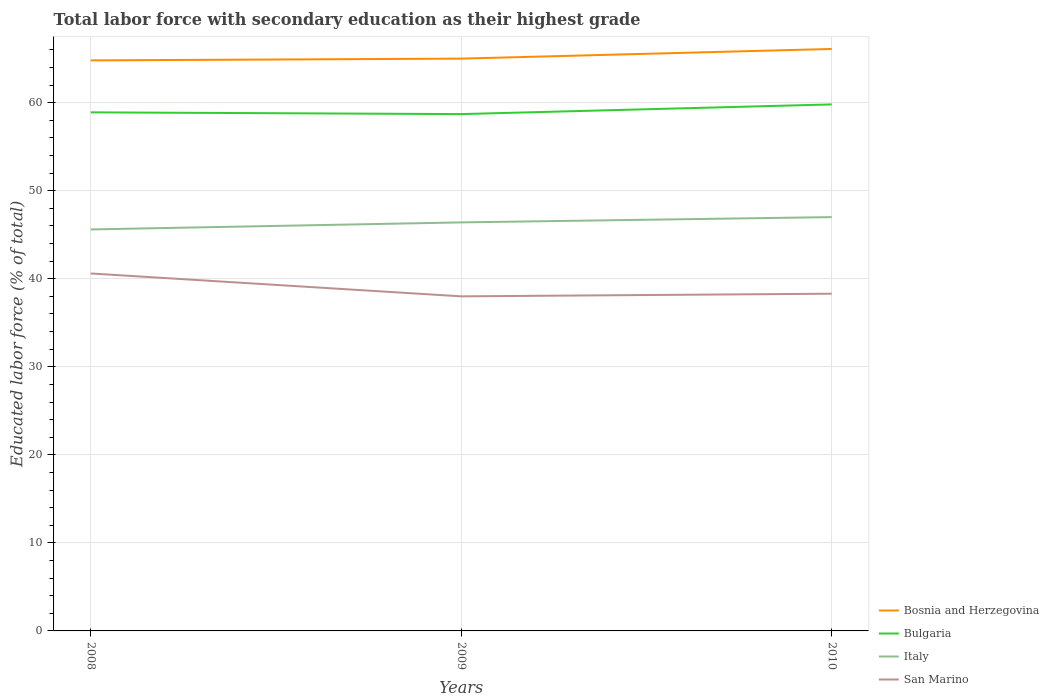Is the number of lines equal to the number of legend labels?
Make the answer very short. Yes. Across all years, what is the maximum percentage of total labor force with primary education in Italy?
Your answer should be very brief. 45.6. In which year was the percentage of total labor force with primary education in Italy maximum?
Provide a short and direct response. 2008. What is the total percentage of total labor force with primary education in Bulgaria in the graph?
Your answer should be very brief. -0.9. What is the difference between the highest and the second highest percentage of total labor force with primary education in San Marino?
Your answer should be very brief. 2.6. What is the difference between the highest and the lowest percentage of total labor force with primary education in San Marino?
Give a very brief answer. 1. Is the percentage of total labor force with primary education in Bulgaria strictly greater than the percentage of total labor force with primary education in Bosnia and Herzegovina over the years?
Offer a very short reply. Yes. How many lines are there?
Ensure brevity in your answer.  4. What is the difference between two consecutive major ticks on the Y-axis?
Provide a short and direct response. 10. Are the values on the major ticks of Y-axis written in scientific E-notation?
Your response must be concise. No. Does the graph contain any zero values?
Give a very brief answer. No. Does the graph contain grids?
Give a very brief answer. Yes. How many legend labels are there?
Provide a short and direct response. 4. What is the title of the graph?
Offer a very short reply. Total labor force with secondary education as their highest grade. Does "Puerto Rico" appear as one of the legend labels in the graph?
Your response must be concise. No. What is the label or title of the X-axis?
Give a very brief answer. Years. What is the label or title of the Y-axis?
Give a very brief answer. Educated labor force (% of total). What is the Educated labor force (% of total) of Bosnia and Herzegovina in 2008?
Your answer should be compact. 64.8. What is the Educated labor force (% of total) of Bulgaria in 2008?
Offer a very short reply. 58.9. What is the Educated labor force (% of total) in Italy in 2008?
Keep it short and to the point. 45.6. What is the Educated labor force (% of total) in San Marino in 2008?
Give a very brief answer. 40.6. What is the Educated labor force (% of total) of Bosnia and Herzegovina in 2009?
Give a very brief answer. 65. What is the Educated labor force (% of total) in Bulgaria in 2009?
Make the answer very short. 58.7. What is the Educated labor force (% of total) in Italy in 2009?
Keep it short and to the point. 46.4. What is the Educated labor force (% of total) of San Marino in 2009?
Offer a terse response. 38. What is the Educated labor force (% of total) in Bosnia and Herzegovina in 2010?
Provide a succinct answer. 66.1. What is the Educated labor force (% of total) in Bulgaria in 2010?
Your answer should be compact. 59.8. What is the Educated labor force (% of total) of San Marino in 2010?
Give a very brief answer. 38.3. Across all years, what is the maximum Educated labor force (% of total) in Bosnia and Herzegovina?
Offer a very short reply. 66.1. Across all years, what is the maximum Educated labor force (% of total) of Bulgaria?
Offer a very short reply. 59.8. Across all years, what is the maximum Educated labor force (% of total) of San Marino?
Your answer should be compact. 40.6. Across all years, what is the minimum Educated labor force (% of total) of Bosnia and Herzegovina?
Offer a very short reply. 64.8. Across all years, what is the minimum Educated labor force (% of total) of Bulgaria?
Your answer should be very brief. 58.7. Across all years, what is the minimum Educated labor force (% of total) in Italy?
Your answer should be very brief. 45.6. What is the total Educated labor force (% of total) of Bosnia and Herzegovina in the graph?
Give a very brief answer. 195.9. What is the total Educated labor force (% of total) in Bulgaria in the graph?
Make the answer very short. 177.4. What is the total Educated labor force (% of total) of Italy in the graph?
Your answer should be compact. 139. What is the total Educated labor force (% of total) in San Marino in the graph?
Make the answer very short. 116.9. What is the difference between the Educated labor force (% of total) of Bulgaria in 2008 and that in 2009?
Your answer should be very brief. 0.2. What is the difference between the Educated labor force (% of total) of Italy in 2008 and that in 2009?
Give a very brief answer. -0.8. What is the difference between the Educated labor force (% of total) in Bosnia and Herzegovina in 2008 and that in 2010?
Make the answer very short. -1.3. What is the difference between the Educated labor force (% of total) of Italy in 2008 and that in 2010?
Give a very brief answer. -1.4. What is the difference between the Educated labor force (% of total) in San Marino in 2008 and that in 2010?
Give a very brief answer. 2.3. What is the difference between the Educated labor force (% of total) of Bosnia and Herzegovina in 2008 and the Educated labor force (% of total) of San Marino in 2009?
Ensure brevity in your answer.  26.8. What is the difference between the Educated labor force (% of total) in Bulgaria in 2008 and the Educated labor force (% of total) in Italy in 2009?
Make the answer very short. 12.5. What is the difference between the Educated labor force (% of total) of Bulgaria in 2008 and the Educated labor force (% of total) of San Marino in 2009?
Offer a very short reply. 20.9. What is the difference between the Educated labor force (% of total) of Italy in 2008 and the Educated labor force (% of total) of San Marino in 2009?
Your response must be concise. 7.6. What is the difference between the Educated labor force (% of total) in Bosnia and Herzegovina in 2008 and the Educated labor force (% of total) in Italy in 2010?
Offer a terse response. 17.8. What is the difference between the Educated labor force (% of total) in Bulgaria in 2008 and the Educated labor force (% of total) in Italy in 2010?
Offer a very short reply. 11.9. What is the difference between the Educated labor force (% of total) of Bulgaria in 2008 and the Educated labor force (% of total) of San Marino in 2010?
Your answer should be very brief. 20.6. What is the difference between the Educated labor force (% of total) of Bosnia and Herzegovina in 2009 and the Educated labor force (% of total) of Italy in 2010?
Your answer should be very brief. 18. What is the difference between the Educated labor force (% of total) in Bosnia and Herzegovina in 2009 and the Educated labor force (% of total) in San Marino in 2010?
Offer a terse response. 26.7. What is the difference between the Educated labor force (% of total) in Bulgaria in 2009 and the Educated labor force (% of total) in San Marino in 2010?
Provide a short and direct response. 20.4. What is the difference between the Educated labor force (% of total) of Italy in 2009 and the Educated labor force (% of total) of San Marino in 2010?
Your answer should be compact. 8.1. What is the average Educated labor force (% of total) in Bosnia and Herzegovina per year?
Ensure brevity in your answer.  65.3. What is the average Educated labor force (% of total) in Bulgaria per year?
Offer a terse response. 59.13. What is the average Educated labor force (% of total) in Italy per year?
Your response must be concise. 46.33. What is the average Educated labor force (% of total) in San Marino per year?
Ensure brevity in your answer.  38.97. In the year 2008, what is the difference between the Educated labor force (% of total) in Bosnia and Herzegovina and Educated labor force (% of total) in Bulgaria?
Ensure brevity in your answer.  5.9. In the year 2008, what is the difference between the Educated labor force (% of total) in Bosnia and Herzegovina and Educated labor force (% of total) in San Marino?
Your response must be concise. 24.2. In the year 2008, what is the difference between the Educated labor force (% of total) in Bulgaria and Educated labor force (% of total) in Italy?
Provide a short and direct response. 13.3. In the year 2009, what is the difference between the Educated labor force (% of total) of Bosnia and Herzegovina and Educated labor force (% of total) of Bulgaria?
Ensure brevity in your answer.  6.3. In the year 2009, what is the difference between the Educated labor force (% of total) in Bulgaria and Educated labor force (% of total) in Italy?
Your response must be concise. 12.3. In the year 2009, what is the difference between the Educated labor force (% of total) in Bulgaria and Educated labor force (% of total) in San Marino?
Offer a terse response. 20.7. In the year 2010, what is the difference between the Educated labor force (% of total) of Bosnia and Herzegovina and Educated labor force (% of total) of San Marino?
Provide a succinct answer. 27.8. In the year 2010, what is the difference between the Educated labor force (% of total) in Italy and Educated labor force (% of total) in San Marino?
Provide a succinct answer. 8.7. What is the ratio of the Educated labor force (% of total) of Italy in 2008 to that in 2009?
Your answer should be compact. 0.98. What is the ratio of the Educated labor force (% of total) of San Marino in 2008 to that in 2009?
Provide a succinct answer. 1.07. What is the ratio of the Educated labor force (% of total) of Bosnia and Herzegovina in 2008 to that in 2010?
Your answer should be very brief. 0.98. What is the ratio of the Educated labor force (% of total) of Bulgaria in 2008 to that in 2010?
Offer a very short reply. 0.98. What is the ratio of the Educated labor force (% of total) of Italy in 2008 to that in 2010?
Ensure brevity in your answer.  0.97. What is the ratio of the Educated labor force (% of total) in San Marino in 2008 to that in 2010?
Offer a very short reply. 1.06. What is the ratio of the Educated labor force (% of total) of Bosnia and Herzegovina in 2009 to that in 2010?
Ensure brevity in your answer.  0.98. What is the ratio of the Educated labor force (% of total) of Bulgaria in 2009 to that in 2010?
Ensure brevity in your answer.  0.98. What is the ratio of the Educated labor force (% of total) of Italy in 2009 to that in 2010?
Ensure brevity in your answer.  0.99. What is the ratio of the Educated labor force (% of total) in San Marino in 2009 to that in 2010?
Ensure brevity in your answer.  0.99. What is the difference between the highest and the second highest Educated labor force (% of total) in Bosnia and Herzegovina?
Give a very brief answer. 1.1. What is the difference between the highest and the second highest Educated labor force (% of total) in Italy?
Provide a succinct answer. 0.6. What is the difference between the highest and the second highest Educated labor force (% of total) in San Marino?
Your response must be concise. 2.3. What is the difference between the highest and the lowest Educated labor force (% of total) in Bosnia and Herzegovina?
Your answer should be compact. 1.3. What is the difference between the highest and the lowest Educated labor force (% of total) of Bulgaria?
Offer a very short reply. 1.1. 